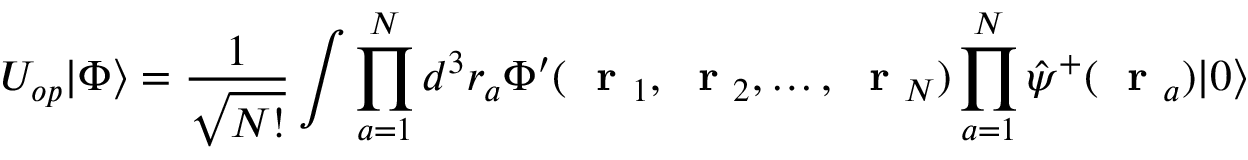<formula> <loc_0><loc_0><loc_500><loc_500>U _ { o p } | \Phi \rangle = \frac { 1 } { \sqrt { N ! } } \int \prod _ { a = 1 } ^ { N } d ^ { 3 } r _ { a } \Phi ^ { \prime } ( r _ { 1 } , r _ { 2 } , \dots , r _ { N } ) \prod _ { a = 1 } ^ { N } \hat { \psi } ^ { + } ( r _ { a } ) | 0 \rangle</formula> 